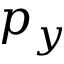Convert formula to latex. <formula><loc_0><loc_0><loc_500><loc_500>p _ { y }</formula> 